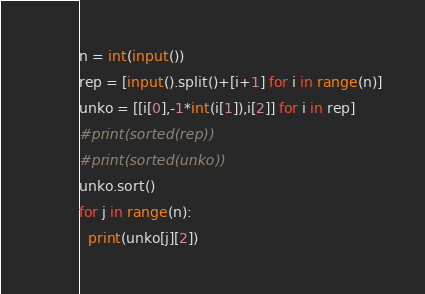<code> <loc_0><loc_0><loc_500><loc_500><_Python_>n = int(input())
rep = [input().split()+[i+1] for i in range(n)]
unko = [[i[0],-1*int(i[1]),i[2]] for i in rep]
#print(sorted(rep))
#print(sorted(unko))
unko.sort()
for j in range(n):
  print(unko[j][2])</code> 